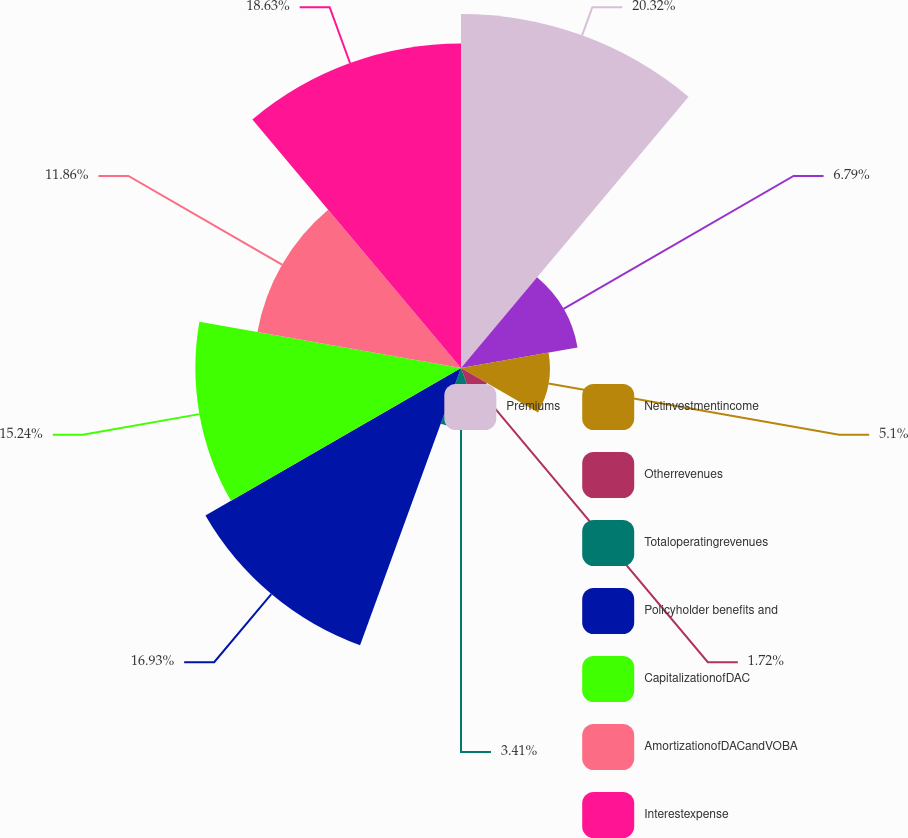Convert chart to OTSL. <chart><loc_0><loc_0><loc_500><loc_500><pie_chart><fcel>Premiums<fcel>Unnamed: 1<fcel>Netinvestmentincome<fcel>Otherrevenues<fcel>Totaloperatingrevenues<fcel>Policyholder benefits and<fcel>CapitalizationofDAC<fcel>AmortizationofDACandVOBA<fcel>Interestexpense<nl><fcel>20.31%<fcel>6.79%<fcel>5.1%<fcel>1.72%<fcel>3.41%<fcel>16.93%<fcel>15.24%<fcel>11.86%<fcel>18.62%<nl></chart> 